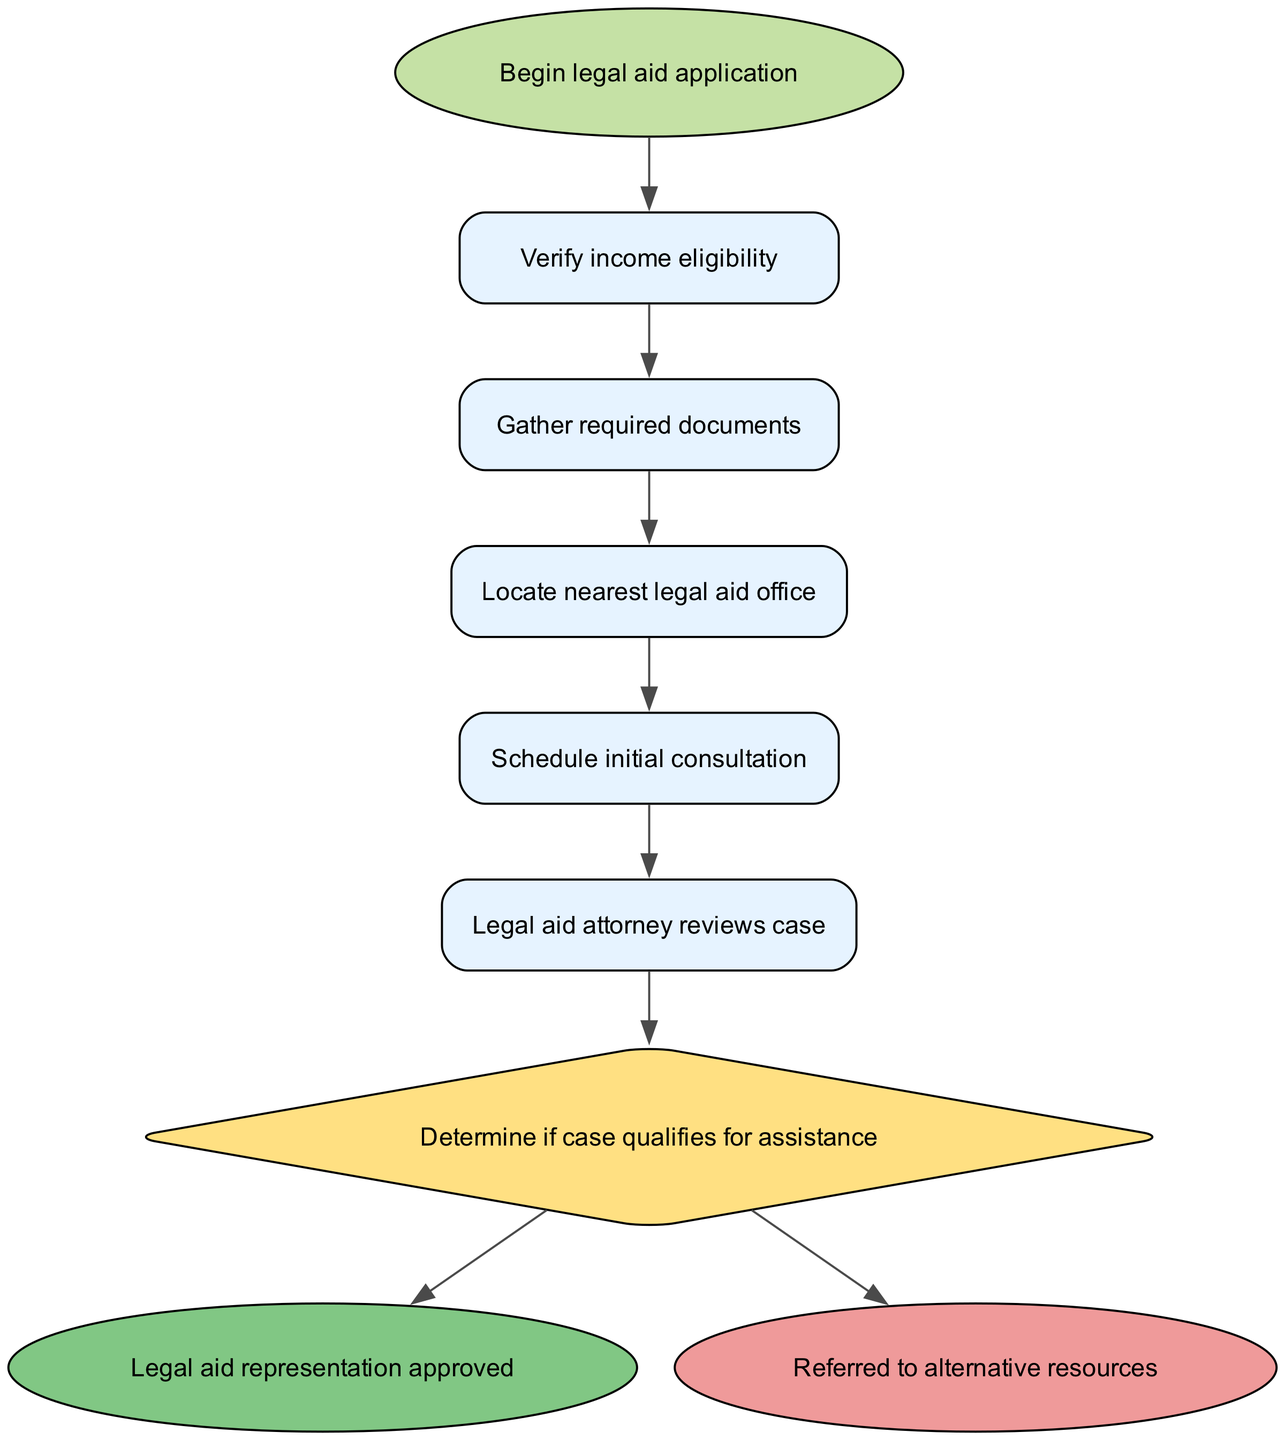What is the first step in the legal aid application process? The diagram indicates that the first step is labeled as "Begin legal aid application," which is represented as the starting point of the flow.
Answer: Begin legal aid application How many nodes are there in the diagram? By counting all the steps and decision points in the diagram, we find there are nine nodes total, including the start and endpoint nodes.
Answer: Nine What document must be gathered after verifying income eligibility? According to the diagram, after verifying income eligibility, the next step is to "Gather required documents."
Answer: Gather required documents What happens after the legal aid attorney reviews the case? The diagram shows that after the "Legal aid attorney reviews case," the flow moves to a decision point labeled "Determine if case qualifies for assistance."
Answer: Determine if case qualifies for assistance If the case does not qualify for assistance, where is the applicant referred? The diagram clearly indicates that if the case is denied, the applicant is "Referred to alternative resources."
Answer: Referred to alternative resources What type of node is 'decision' in the diagram? The node labeled 'decision' is represented as a diamond shape, which is characteristic for decision points in flowcharts.
Answer: Diamond How many outcomes are there after the decision step? After the decision step, the flow chart depicts two outcomes: one leads to "Legal aid representation approved," and the other leads to "Referred to alternative resources," totaling two outcomes.
Answer: Two What is the shape of the node that indicates the start of the process? The start node is depicted as an ellipse, which visually differentiates it as the initiation point in the flowchart.
Answer: Ellipse What is the last step in the legal aid application process? Looking at the flow chart's conclusion, the last step for the approved path is "Legal aid representation approved."
Answer: Legal aid representation approved 